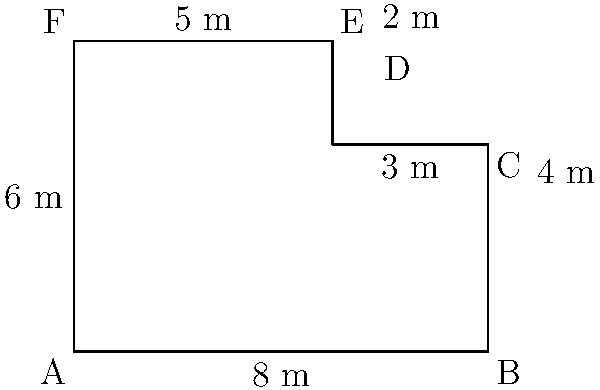After picking up your children from daycare, you notice the playground needs new fencing. The playground has an irregular shape as shown in the diagram. Calculate the perimeter of the playground to determine how much fencing is needed. Round your answer to the nearest meter. Let's calculate the perimeter by adding up all the sides of the playground:

1. Side AB: 8 m
2. Side BC: 4 m
3. Side CD: 3 m
4. Side DE: 2 m
5. Side EF: 5 m
6. Side FA: 6 m

Total perimeter = AB + BC + CD + DE + EF + FA
$$ \text{Perimeter} = 8 + 4 + 3 + 2 + 5 + 6 = 28 \text{ m} $$

Since the question asks to round to the nearest meter, and 28 is already a whole number, no rounding is necessary.
Answer: 28 m 